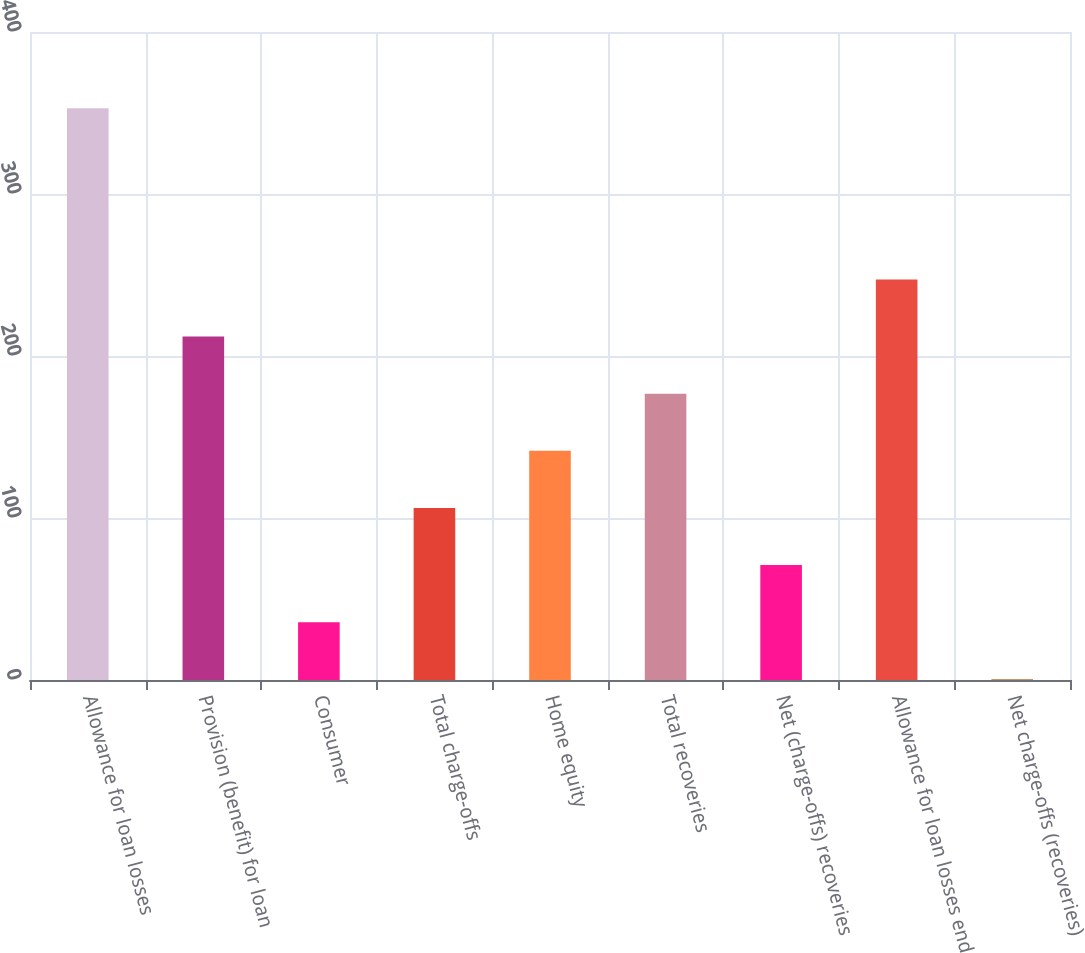<chart> <loc_0><loc_0><loc_500><loc_500><bar_chart><fcel>Allowance for loan losses<fcel>Provision (benefit) for loan<fcel>Consumer<fcel>Total charge-offs<fcel>Home equity<fcel>Total recoveries<fcel>Net (charge-offs) recoveries<fcel>Allowance for loan losses end<fcel>Net charge-offs (recoveries)<nl><fcel>353<fcel>211.96<fcel>35.66<fcel>106.18<fcel>141.44<fcel>176.7<fcel>70.92<fcel>247.22<fcel>0.4<nl></chart> 